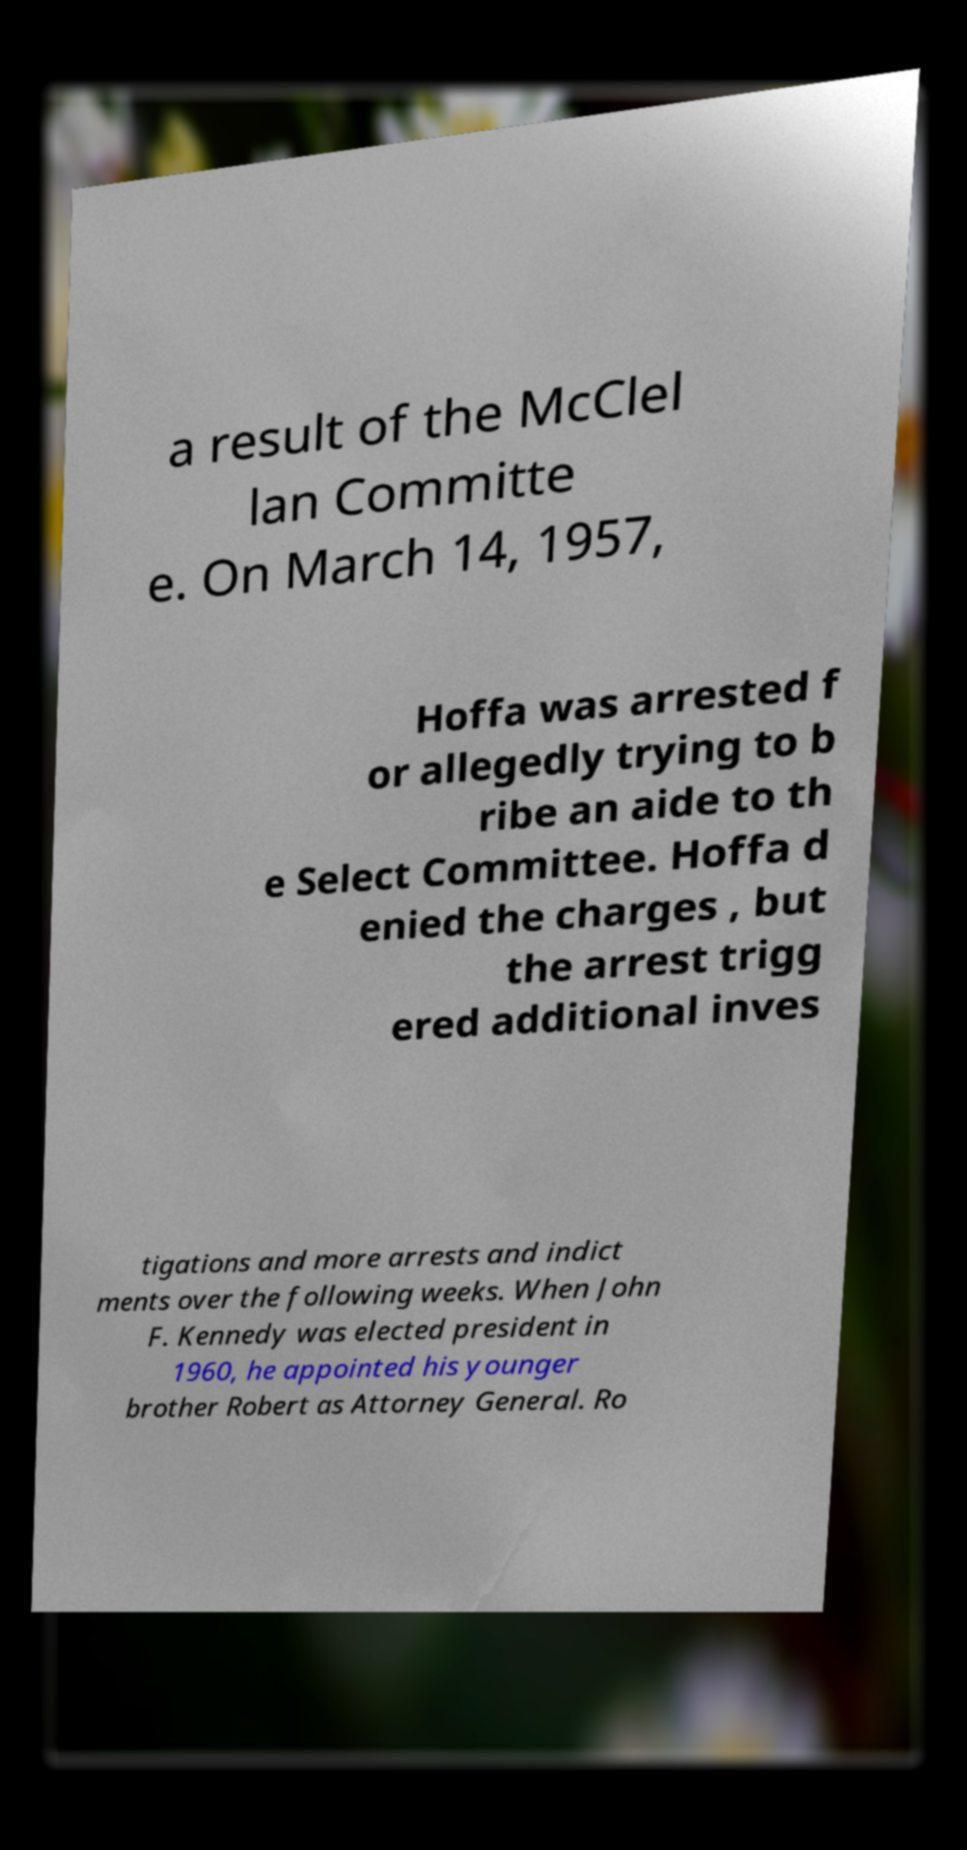Could you assist in decoding the text presented in this image and type it out clearly? a result of the McClel lan Committe e. On March 14, 1957, Hoffa was arrested f or allegedly trying to b ribe an aide to th e Select Committee. Hoffa d enied the charges , but the arrest trigg ered additional inves tigations and more arrests and indict ments over the following weeks. When John F. Kennedy was elected president in 1960, he appointed his younger brother Robert as Attorney General. Ro 